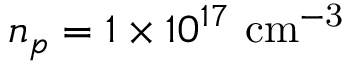Convert formula to latex. <formula><loc_0><loc_0><loc_500><loc_500>n _ { p } = 1 \times 1 0 ^ { 1 7 } \ c m ^ { - 3 }</formula> 